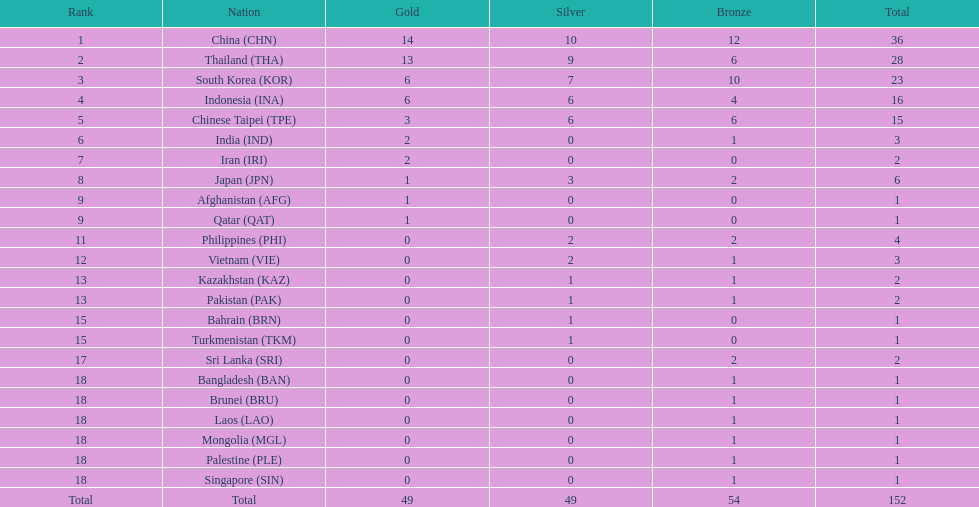In how many countries did no one win any silver medals? 11. 